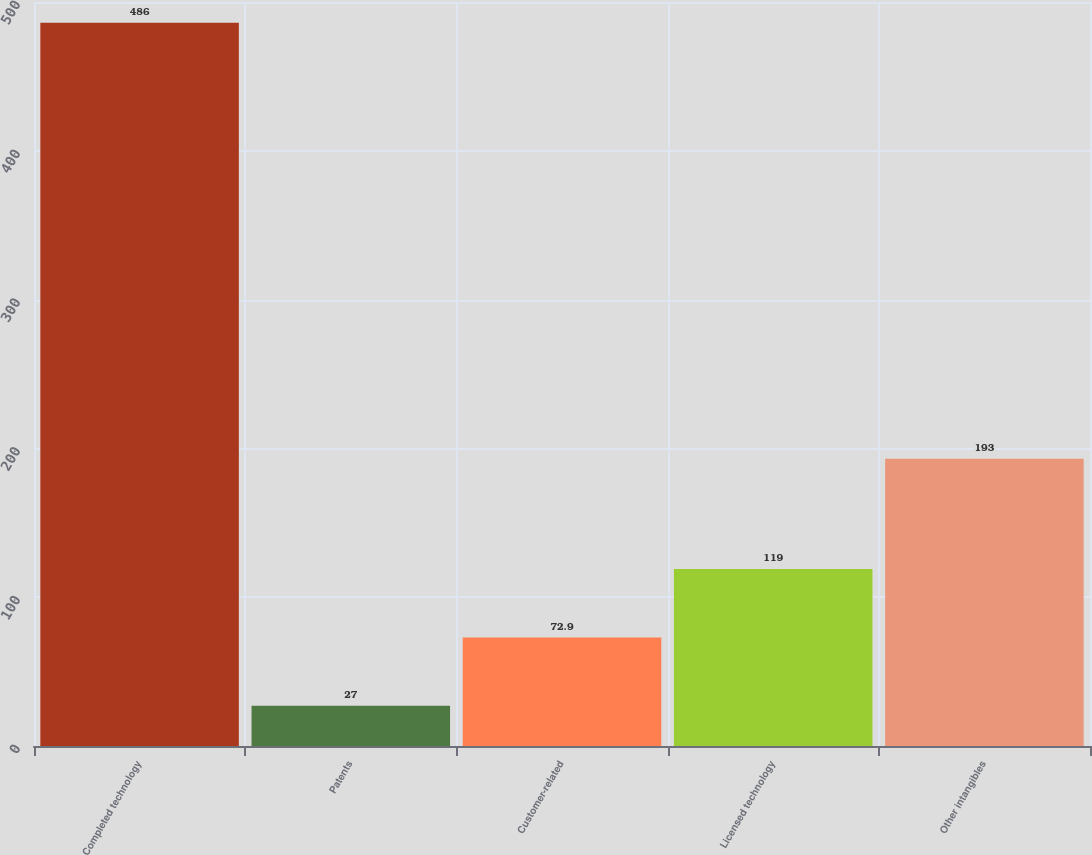Convert chart. <chart><loc_0><loc_0><loc_500><loc_500><bar_chart><fcel>Completed technology<fcel>Patents<fcel>Customer-related<fcel>Licensed technology<fcel>Other intangibles<nl><fcel>486<fcel>27<fcel>72.9<fcel>119<fcel>193<nl></chart> 